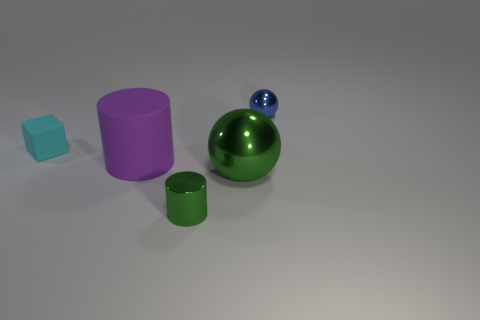What number of cyan cubes are in front of the big green shiny sphere?
Give a very brief answer. 0. Is the number of metallic cylinders greater than the number of small gray shiny cubes?
Offer a very short reply. Yes. What size is the cylinder that is the same color as the big sphere?
Your answer should be compact. Small. There is a object that is both behind the rubber cylinder and to the right of the purple rubber thing; what is its size?
Provide a short and direct response. Small. There is a tiny thing on the right side of the ball on the left side of the shiny object that is behind the big green object; what is its material?
Make the answer very short. Metal. There is a cylinder that is the same color as the big metal object; what is its material?
Provide a succinct answer. Metal. There is a tiny thing that is left of the big purple matte object; is its color the same as the large object in front of the purple cylinder?
Ensure brevity in your answer.  No. There is a small rubber object that is left of the tiny metal thing behind the large object behind the big metal sphere; what shape is it?
Offer a very short reply. Cube. What is the shape of the object that is behind the large green metal object and in front of the small block?
Your response must be concise. Cylinder. How many purple rubber cylinders are on the right side of the shiny ball behind the cylinder behind the green sphere?
Make the answer very short. 0. 